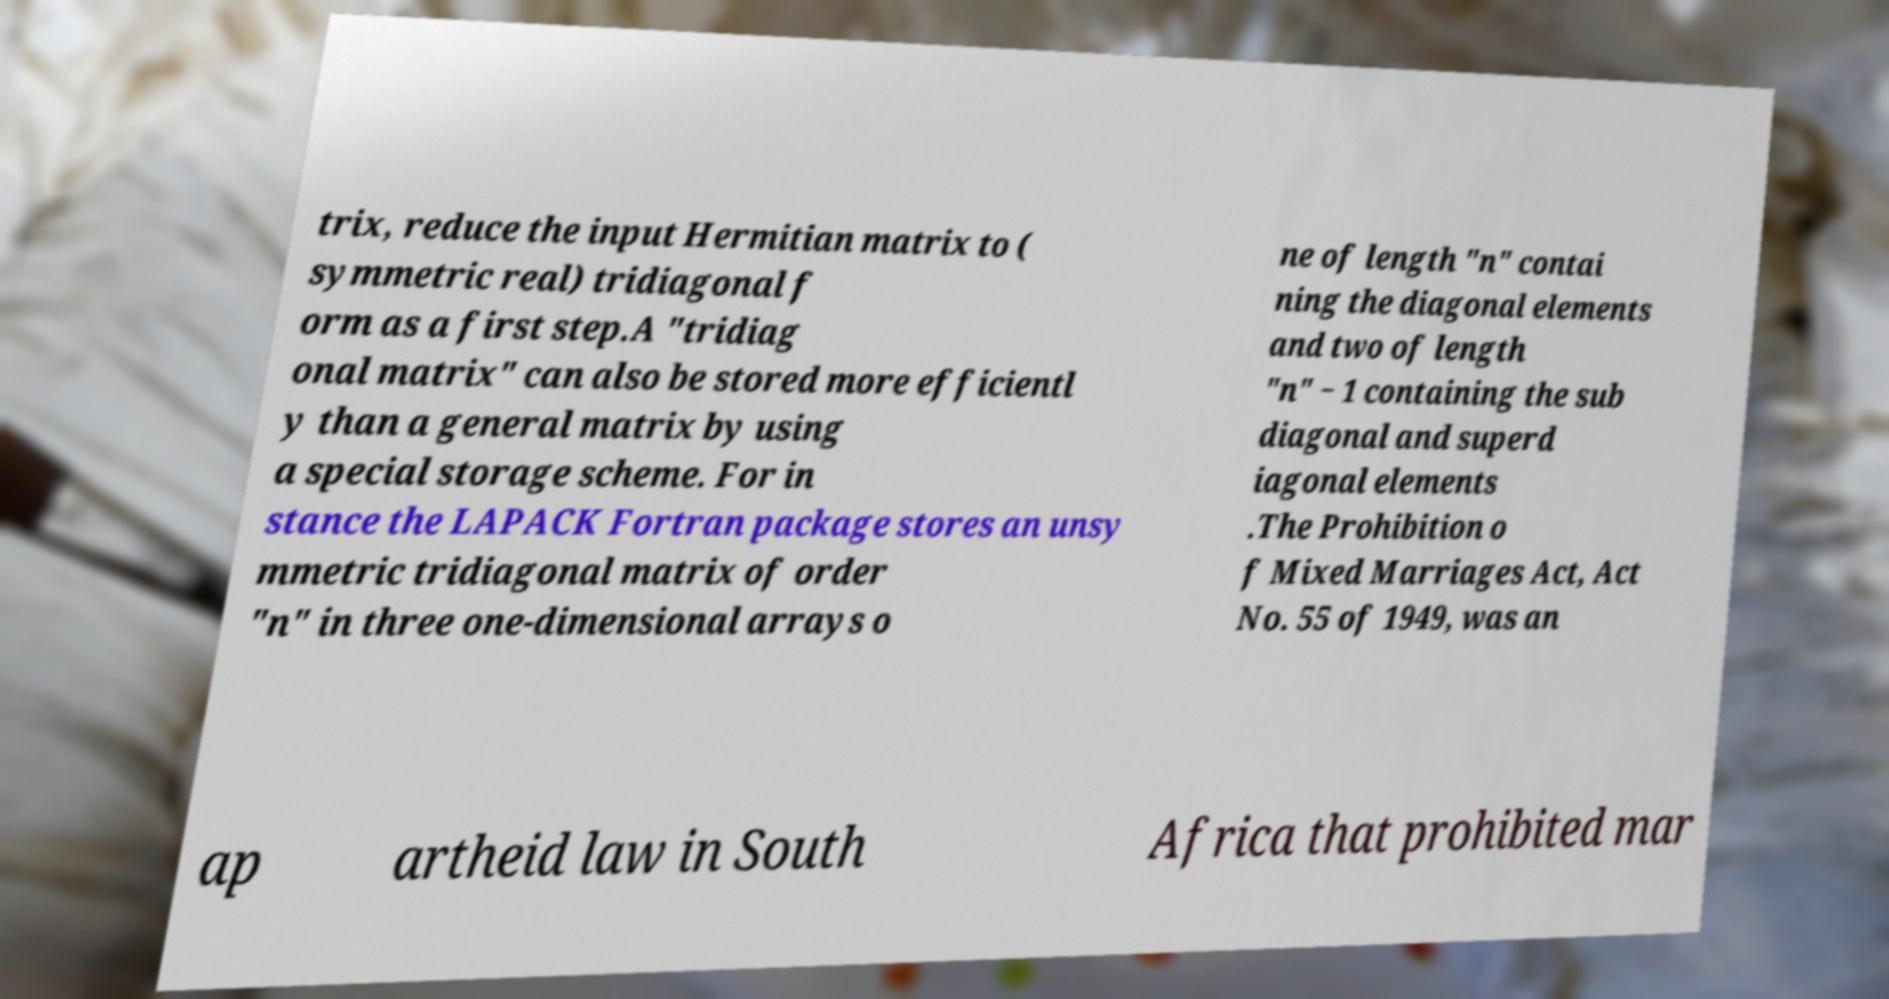Please identify and transcribe the text found in this image. trix, reduce the input Hermitian matrix to ( symmetric real) tridiagonal f orm as a first step.A "tridiag onal matrix" can also be stored more efficientl y than a general matrix by using a special storage scheme. For in stance the LAPACK Fortran package stores an unsy mmetric tridiagonal matrix of order "n" in three one-dimensional arrays o ne of length "n" contai ning the diagonal elements and two of length "n" − 1 containing the sub diagonal and superd iagonal elements .The Prohibition o f Mixed Marriages Act, Act No. 55 of 1949, was an ap artheid law in South Africa that prohibited mar 